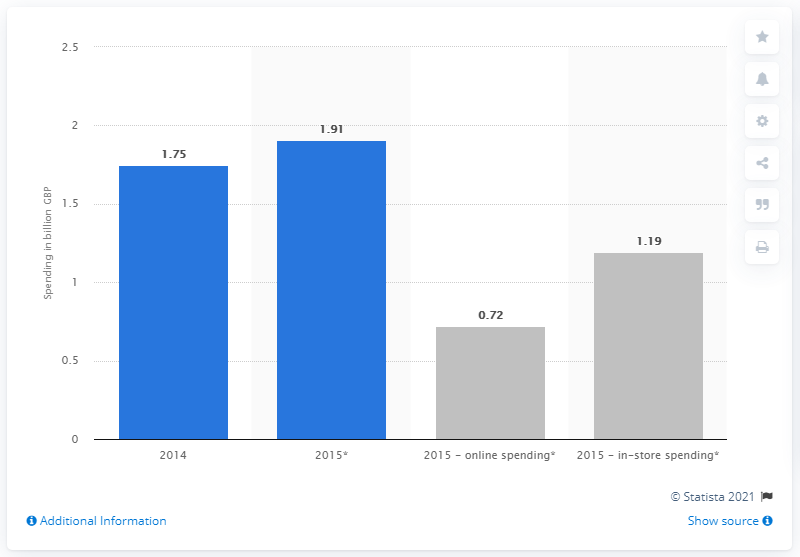Highlight a few significant elements in this photo. In 2014, an estimated 1.75 billion British pounds were spent during Black Friday. How much of the 1.9 billion spent online is expected to be spent on Black Friday in 2015? Approximately 0.72 of it. 